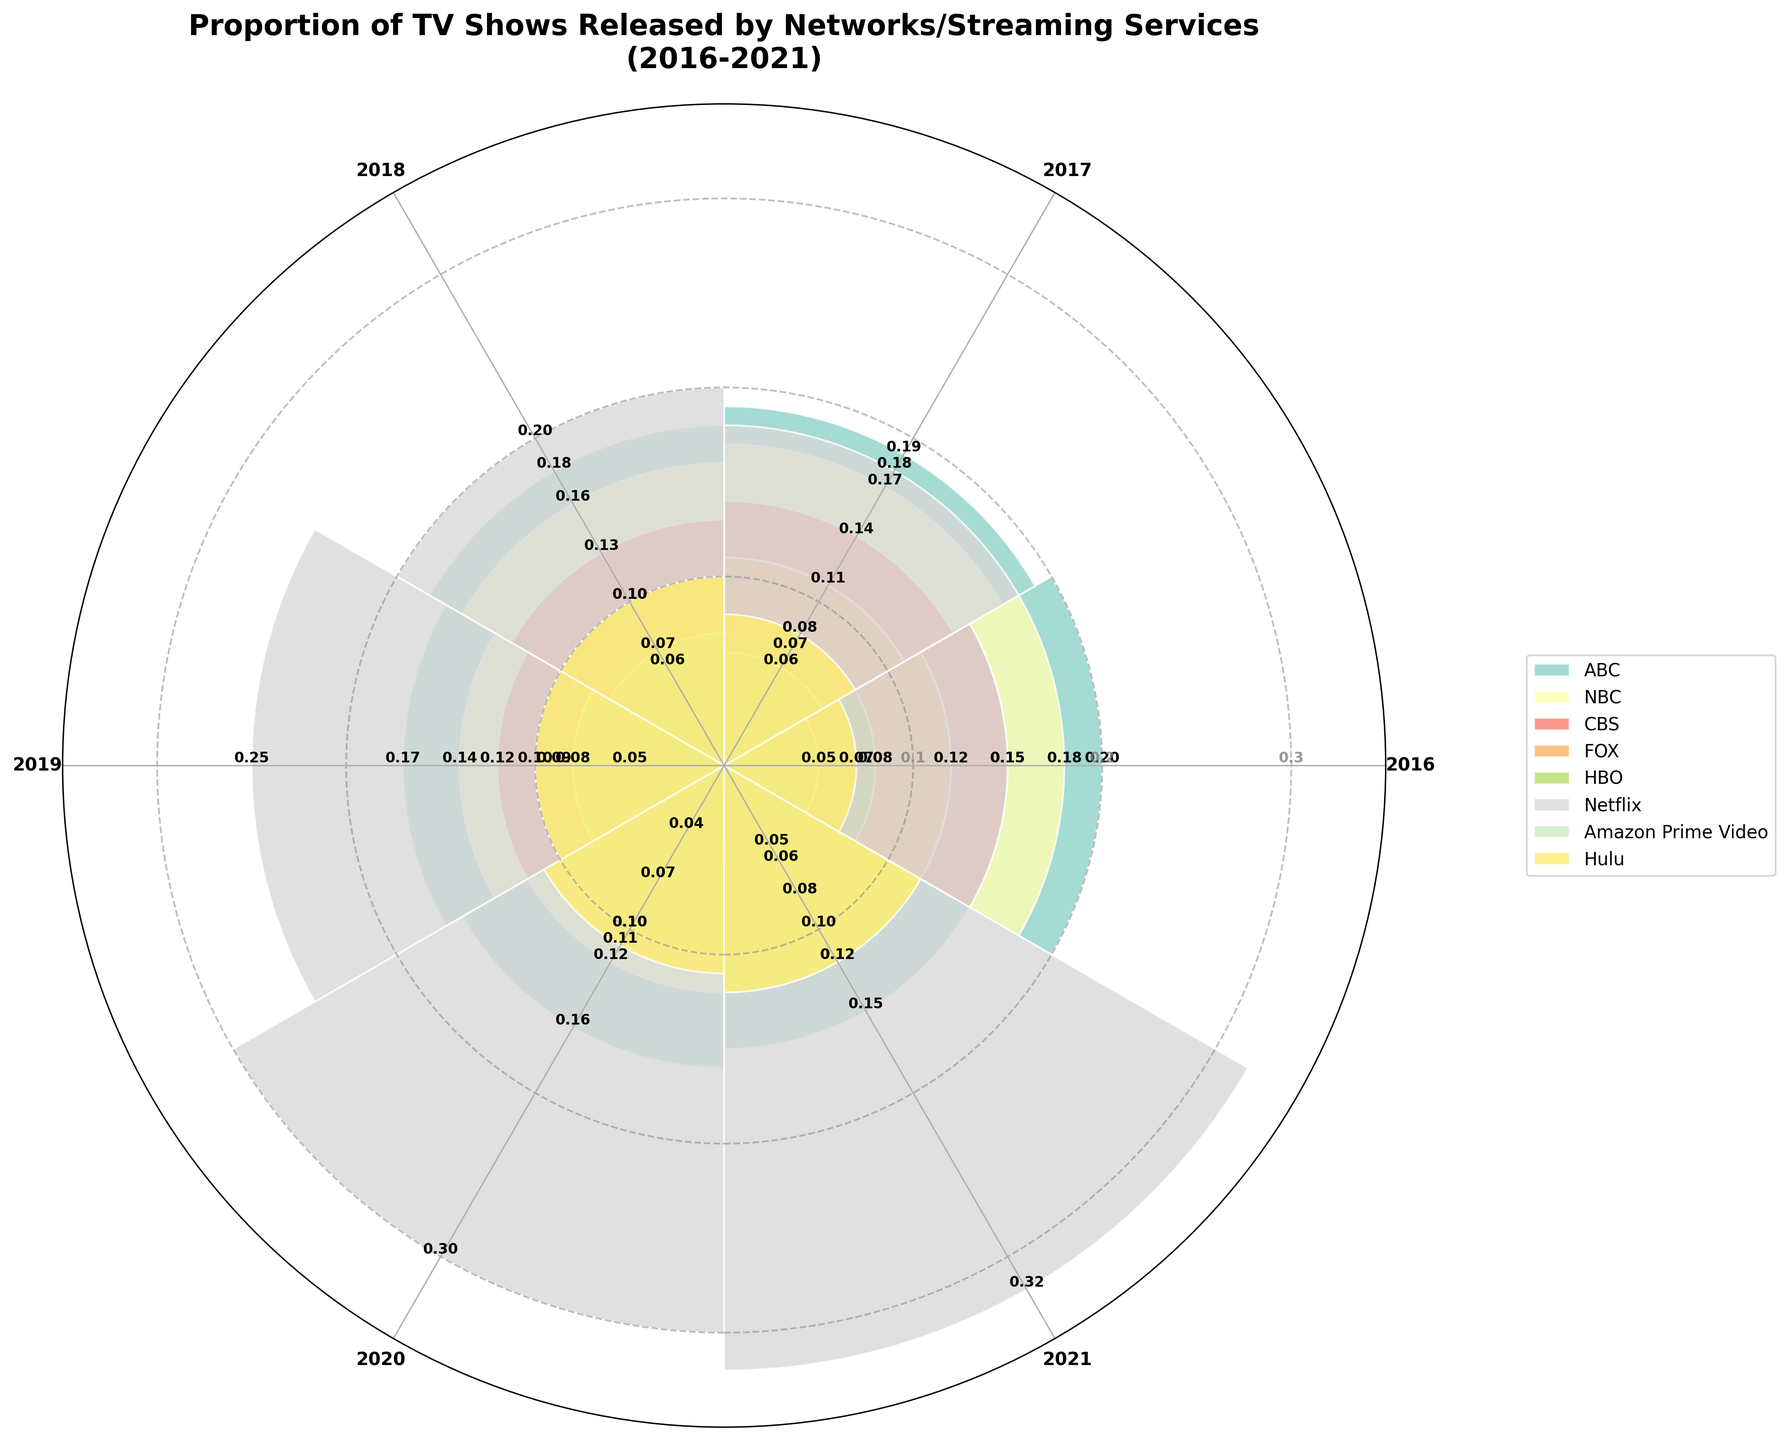What's the title of the chart? The title of the chart is prominently displayed at the top. It reads "Proportion of TV Shows Released by Networks/Streaming Services\n(2016-2021)".
Answer: Proportion of TV Shows Released by Networks/Streaming Services (2016-2021) Which network/streaming service had the highest proportion of TV shows released in 2019? By visually examining the bars in the section labeled "2019," the bar representing Netflix extends the furthest outward.
Answer: Netflix What is the general trend for ABC from 2016 to 2021? Observing the bars for ABC over the years, the proportion of TV shows released gradually decreases from 0.20 in 2016 to 0.15 in 2021.
Answer: Decreasing For which years did Hulu have the same proportion of TV shows released? Looking at the sections for Hulu, the proportions in 2018 and 2019 both reach 0.10.
Answer: 2018 and 2019 What was the combined proportion of TV shows released by Amazon Prime Video and Hulu in 2017? Adding the proportions for Amazon Prime Video (0.06) and Hulu (0.08) in 2017: 0.06 + 0.08 = 0.14.
Answer: 0.14 Which network had a smaller share than HBO in 2016? In 2016, Amazon Prime Video (0.05) and Hulu (0.07) both show bars shorter than HBO (0.08).
Answer: Amazon Prime Video and Hulu Between 2016 and 2021, which streaming service showed the most significant increase in the proportion of TV shows released? Netflix's bar length increases the most noticeably, starting at 0.15 in 2016 and ending at 0.32 in 2021.
Answer: Netflix How many concentric circles showing proportions are annotated on the chart? There are three concentric circles labeled with the proportions 0.1, 0.2, and 0.3.
Answer: Three Which year had the same proportion of TV shows released by CBS and FOX? In 2021, both CBS and FOX released proportions of 0.08 and 0.06 respectively. Observing the same proportion is misleading here. Comparing precisely depicts differences.
Answer: None Which network/streaming service had no change in the proportion of TV shows released between any two consecutive years? Amazon Prime Video's proportions are consistent across at least some consecutive years, notably showing 0.10 for both the years 2020 and 2021.
Answer: Amazon Prime Video 